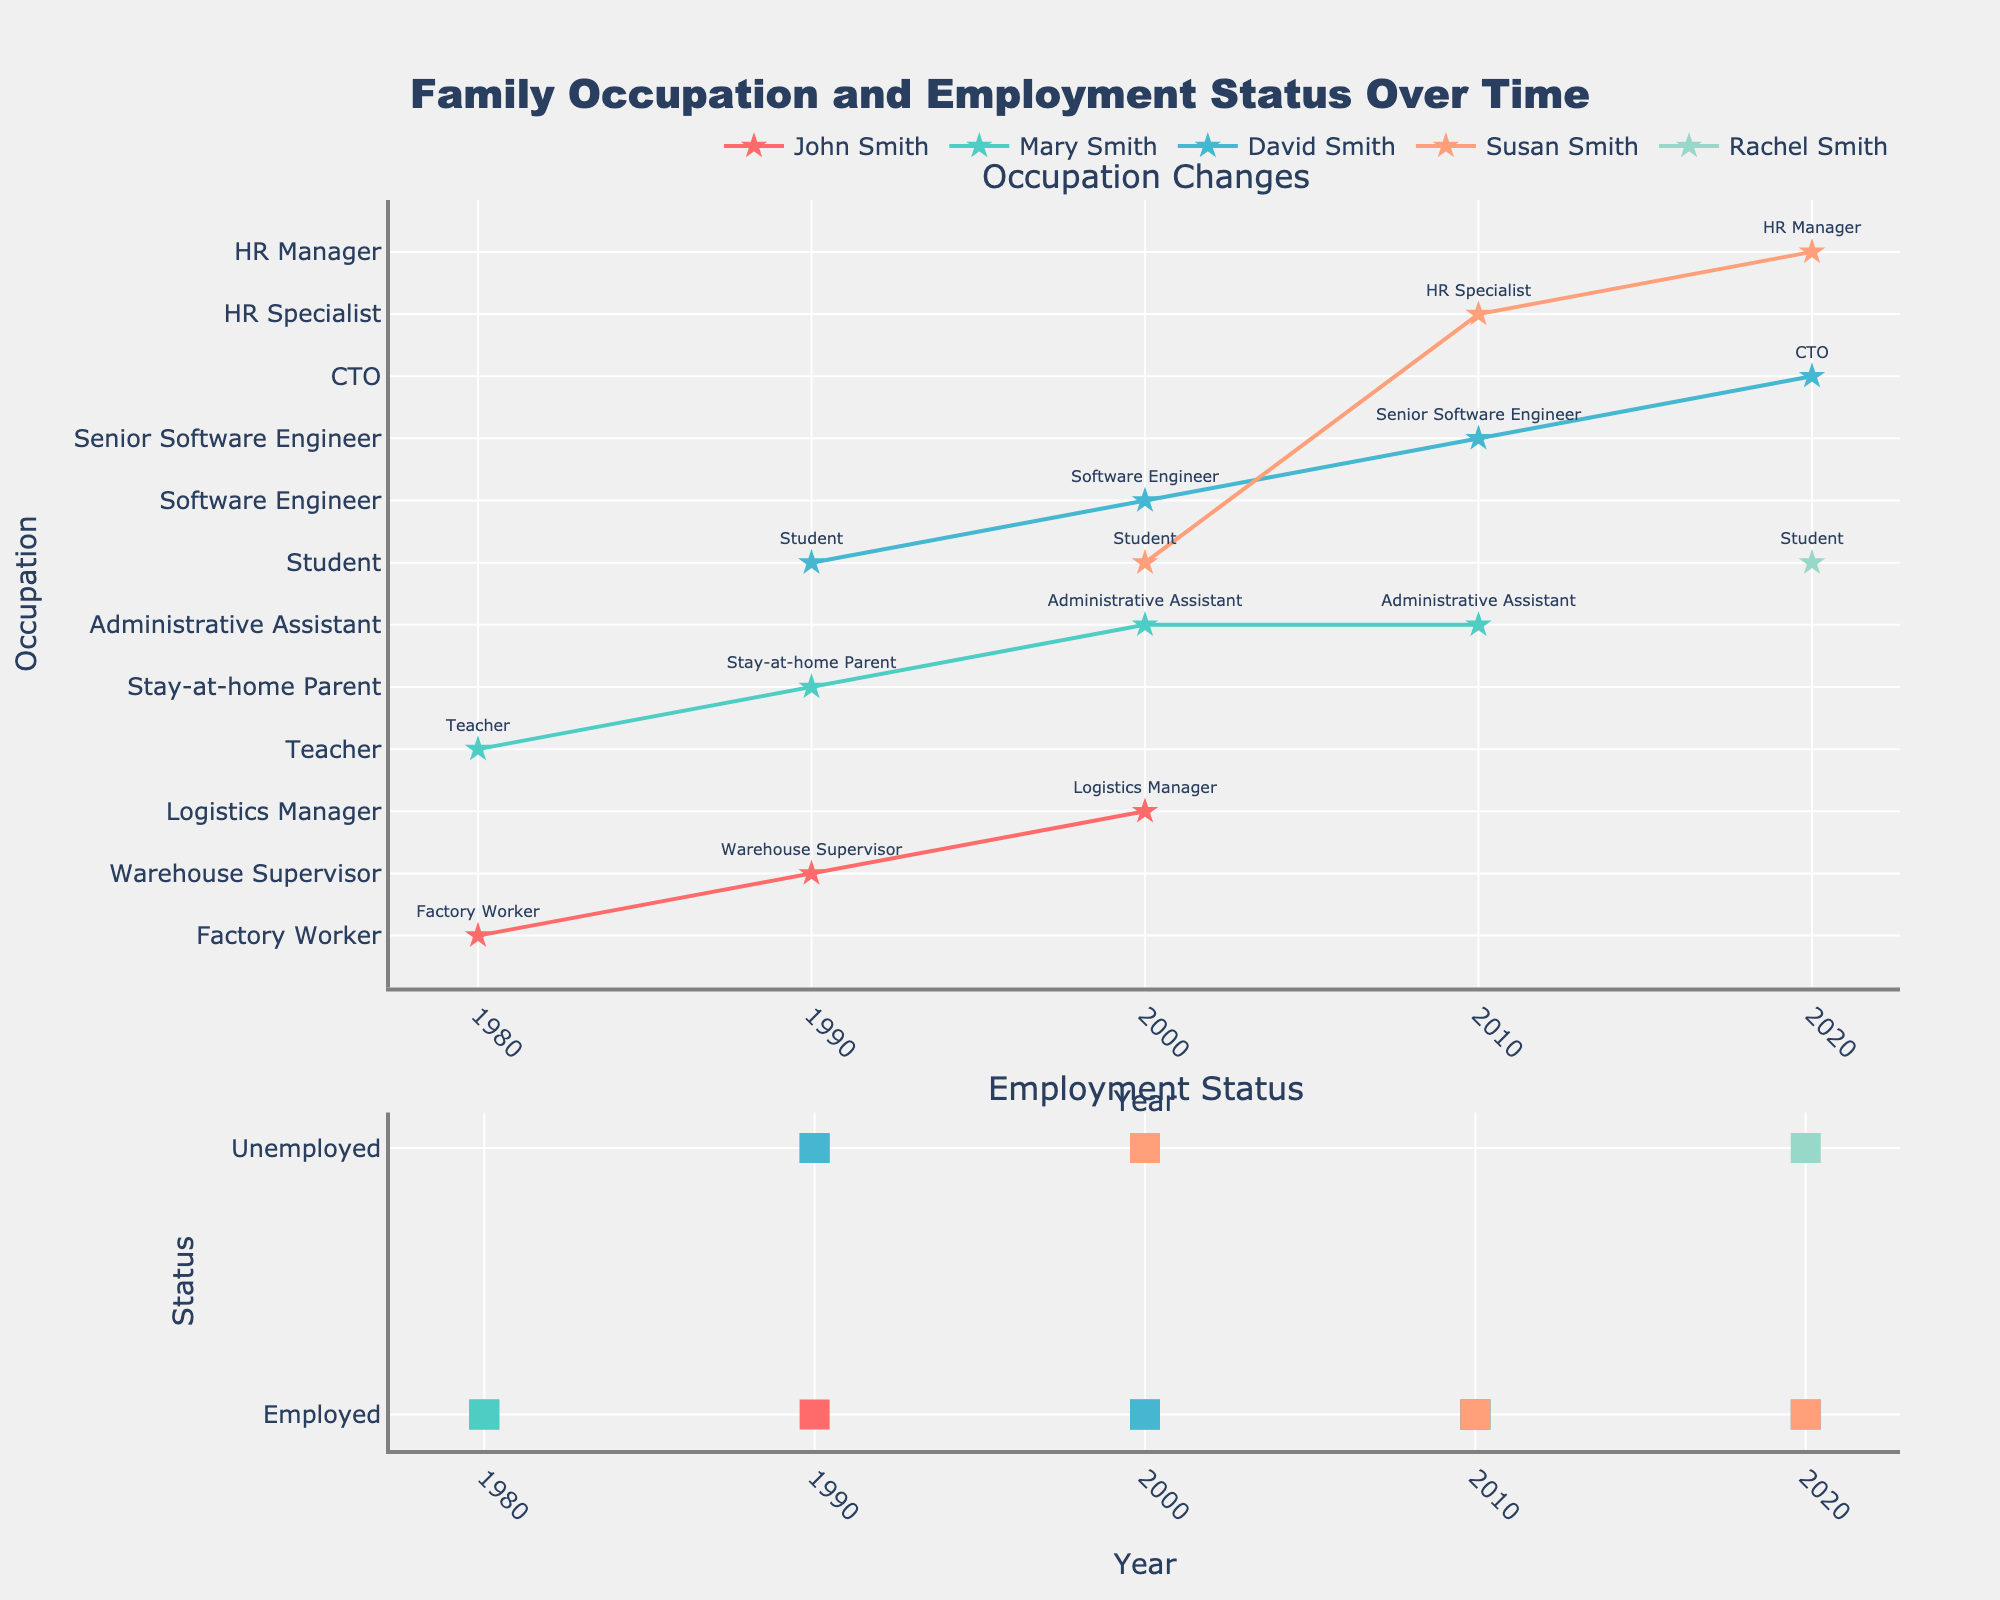What is the occupation of John Smith in the year 2000? Identify John Smith's occupation in the year 2000 from the first subplot which shows occupation over time.
Answer: Logistics Manager How many different occupations has Mary Smith had over the decades? Count the different occupations Mary Smith held by tracing her changes in the first subplot.
Answer: 3 In which year did Susan Smith become employed, and what was her occupation at that time? Look at Susan Smith’s employment status and occupation changes. She became employed in 2010, as shown in the bottom subplot for employment status; her occupation is HR Specialist in the top subplot.
Answer: 2010, HR Specialist Who achieved the highest position in the family by 2020, and what was the position? Compare occupations of all family members in 2020. David Smith's role as CTO is the highest.
Answer: David Smith, CTO What pattern can you observe in Mary Smith’s employment status over the years? Analyze Mary Smith’s employment status in the second subplot. She was employed in 1980, became unemployed in 1990, and then employed again from 2000 to 2010.
Answer: Employed-Unemployed-Employed Which family member had the most significant change in occupation title from 2000 to 2020? Evaluate occupation changes of each family member between 2000 and 2020. David Smith changed from Software Engineer to CTO.
Answer: David Smith How many family members were unemployed in the year 1990? Count the markers indicating "Unemployed" in the employment status subplot for the year 1990.
Answer: 2 Who was a student in the year 2000, and what was their employment status? Look at the first subplot for occupation in 2000 and verify employment status in the second subplot. Susan Smith, unemployed.
Answer: Susan Smith, Unemployed Which person had a continuous employment status from 1980 to 2000, and what was their occupation in the first year and the last year? Trace each person's employment status in the second subplot from 1980 to 2000. John Smith was continuously employed, starting as a Factory Worker and ending as a Logistics Manager.
Answer: John Smith, Factory Worker, Logistics Manager Compare the employment status of David Smith in 2000 and 2020. What change can be observed? Check David Smith's employment status markers for the years 2000 and 2020. He was employed in both years, showing career progression from Software Engineer to CTO.
Answer: Employed to Employed 